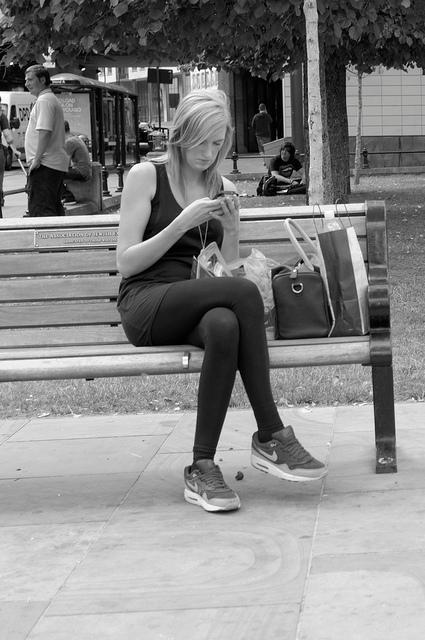What are the shoes that the girl is wearing a good use for?
Answer the question by selecting the correct answer among the 4 following choices.
Options: Ballet, snowboarding, running, swimming. Running. 